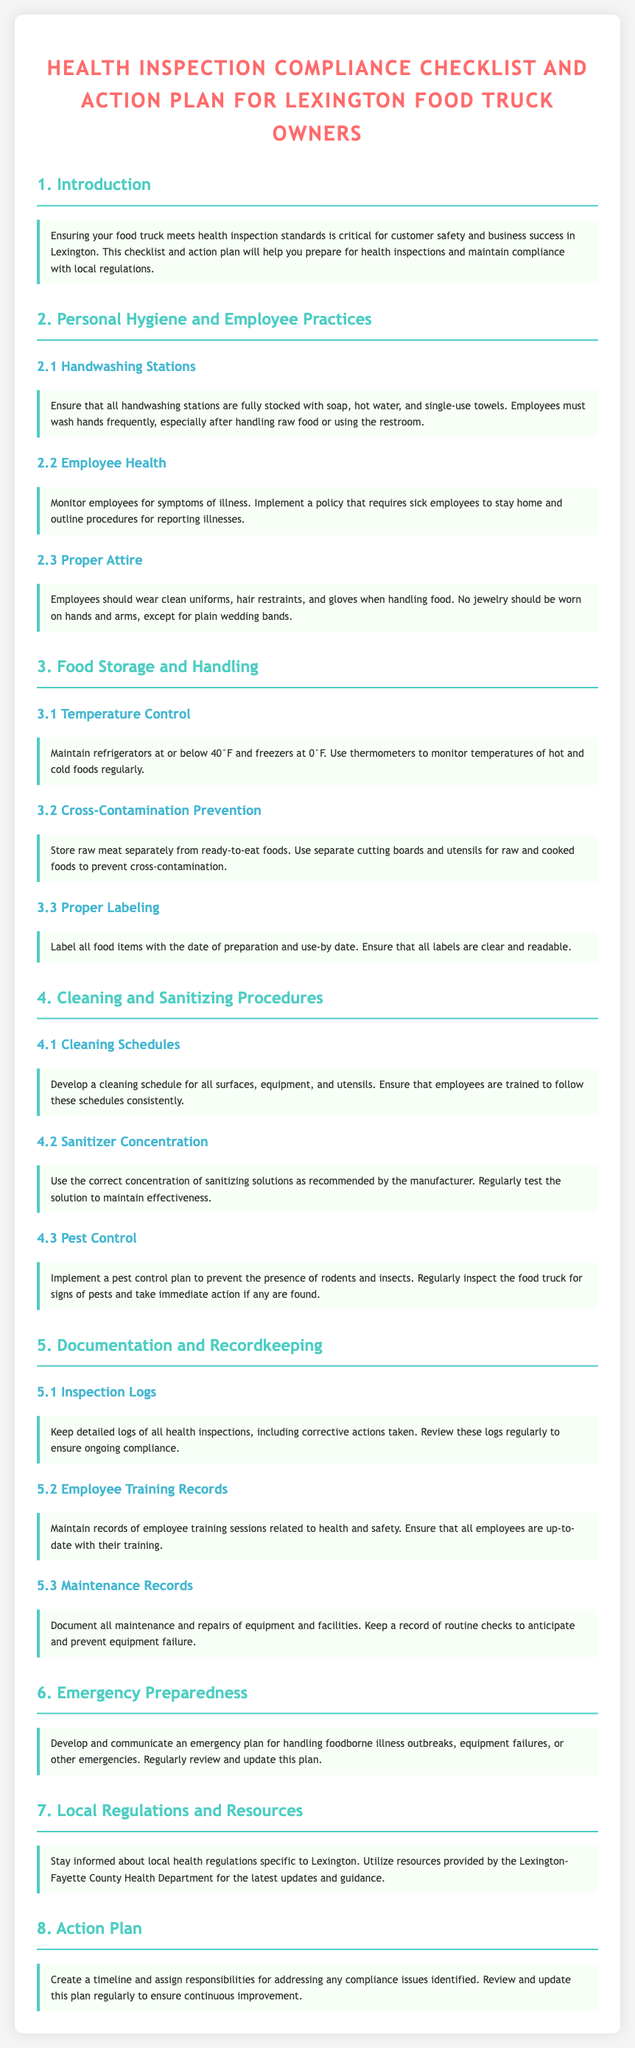what is the title of the document? The title is presented at the top of the document and indicates its purpose for food truck owners.
Answer: Health Inspection Compliance Checklist and Action Plan for Lexington Food Truck Owners how many main sections are in the document? The number of main sections can be counted from the headings in the document.
Answer: Eight what should employees do after using the restroom? This action is referenced in the 'Personal Hygiene and Employee Practices' section regarding handwashing.
Answer: Wash hands what temperature should refrigerators be maintained at? This information is given in the 'Temperature Control' section regarding food storage.
Answer: At or below 40°F what is required for cleaning schedules? This is outlined in the 'Cleaning Schedules' section emphasizing consistency in employee training.
Answer: Consistency what should be kept in the inspection logs? The 'Inspection Logs' section specifies what should be recorded for compliance.
Answer: Detailed logs what does the emergency plan address? The emergency preparedness section outlines the types of issues the plan should cover.
Answer: Foodborne illness outbreaks, equipment failures, or other emergencies what local resource can food truck owners utilize? This relates to the information provided in the 'Local Regulations and Resources' section.
Answer: Lexington-Fayette County Health Department 